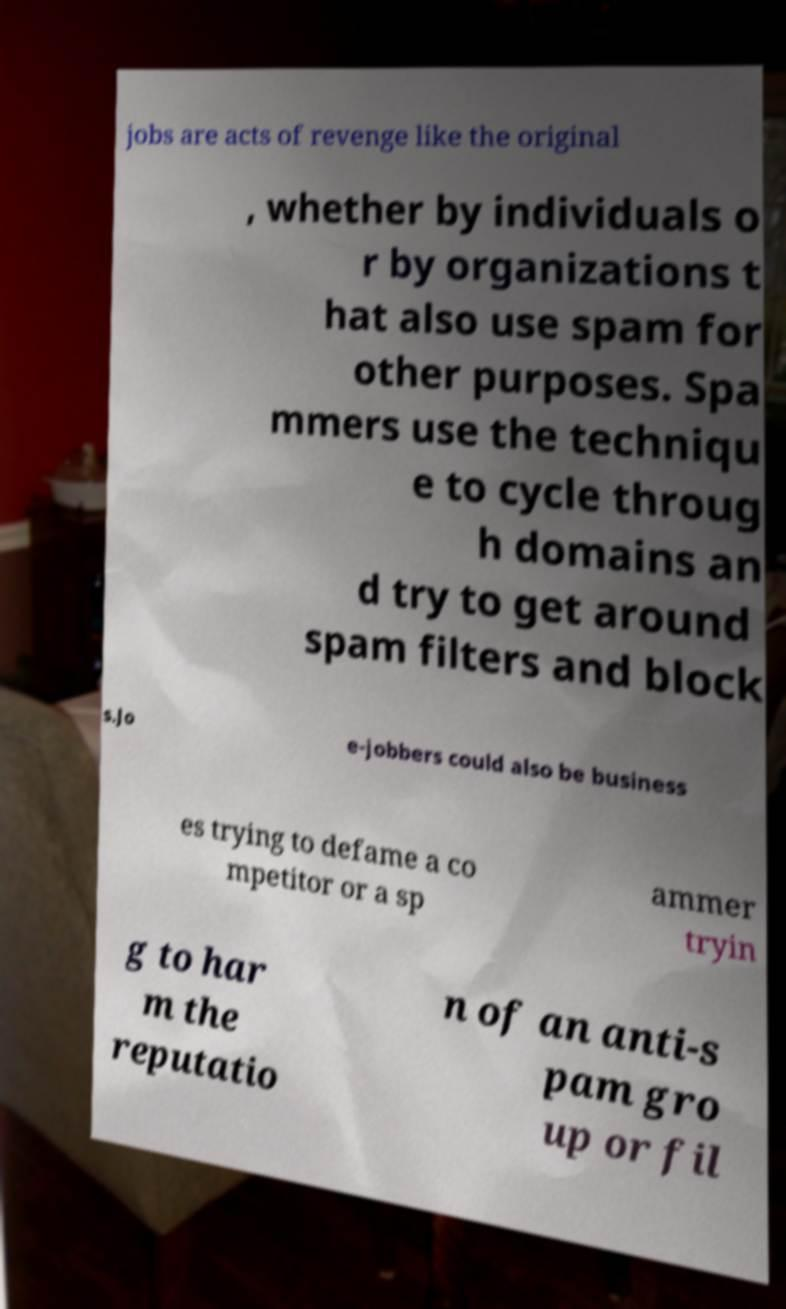Can you read and provide the text displayed in the image?This photo seems to have some interesting text. Can you extract and type it out for me? jobs are acts of revenge like the original , whether by individuals o r by organizations t hat also use spam for other purposes. Spa mmers use the techniqu e to cycle throug h domains an d try to get around spam filters and block s.Jo e-jobbers could also be business es trying to defame a co mpetitor or a sp ammer tryin g to har m the reputatio n of an anti-s pam gro up or fil 